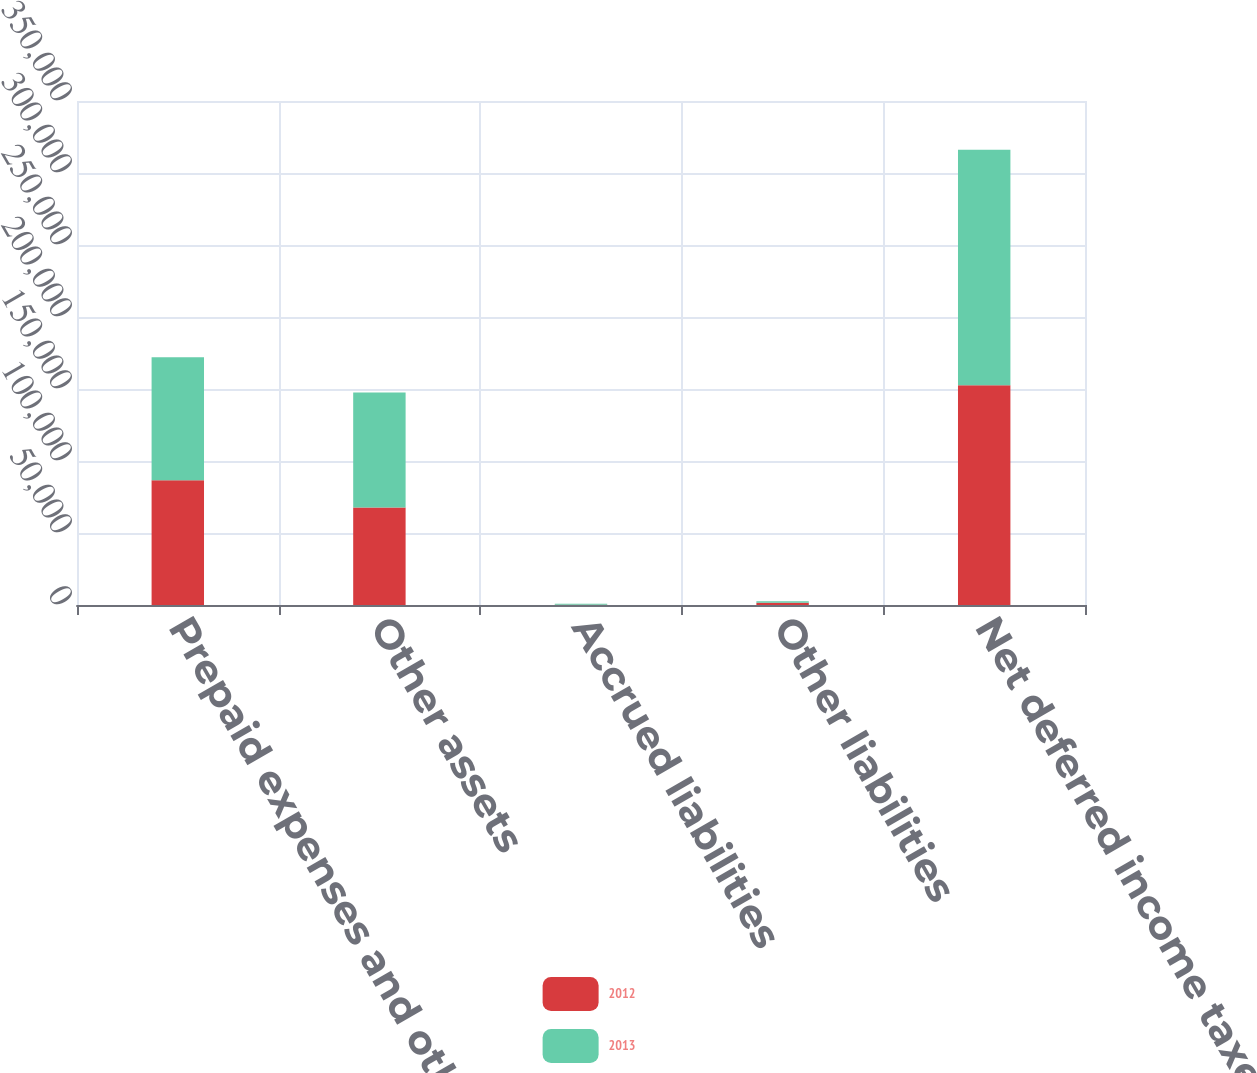Convert chart to OTSL. <chart><loc_0><loc_0><loc_500><loc_500><stacked_bar_chart><ecel><fcel>Prepaid expenses and other<fcel>Other assets<fcel>Accrued liabilities<fcel>Other liabilities<fcel>Net deferred income taxes<nl><fcel>2012<fcel>86634<fcel>67773<fcel>183<fcel>1545<fcel>152679<nl><fcel>2013<fcel>85429<fcel>79746<fcel>641<fcel>1057<fcel>163477<nl></chart> 